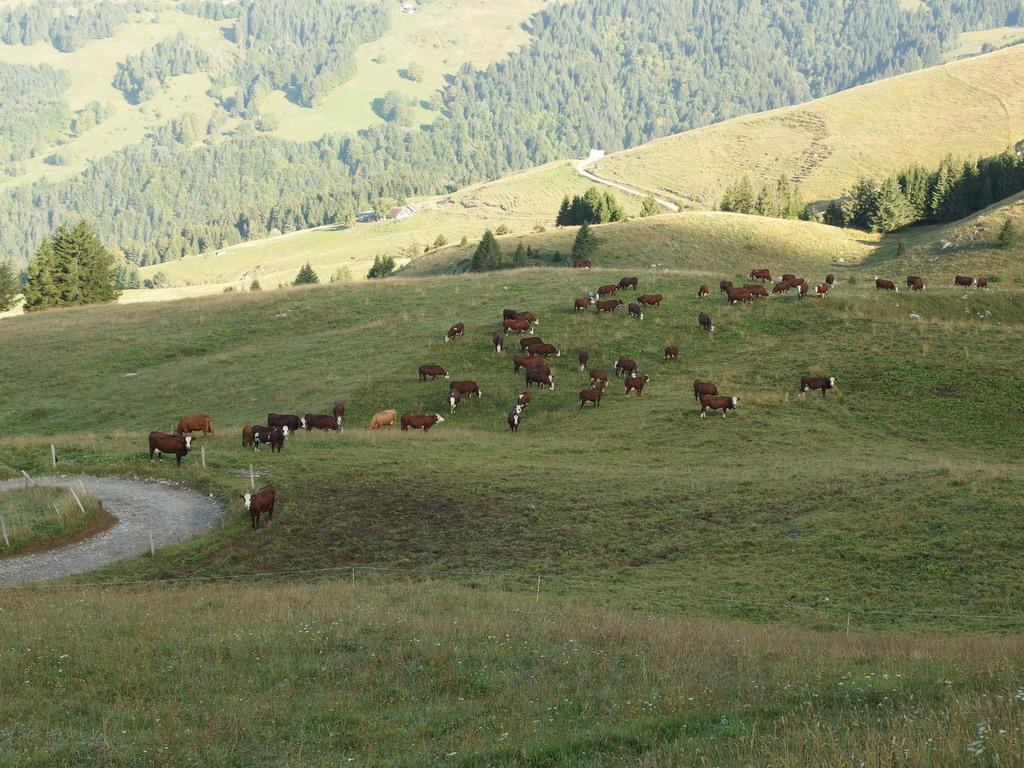What animals are present in the image? There is a herd of sheep in the image. What are the sheep doing in the image? The sheep are grazing. What can be seen on the left side of the image? There are trees on the left side of the image. Where is the swing located in the image? There is no swing present in the image. What type of prose can be read in the image? There is no prose present in the image. 